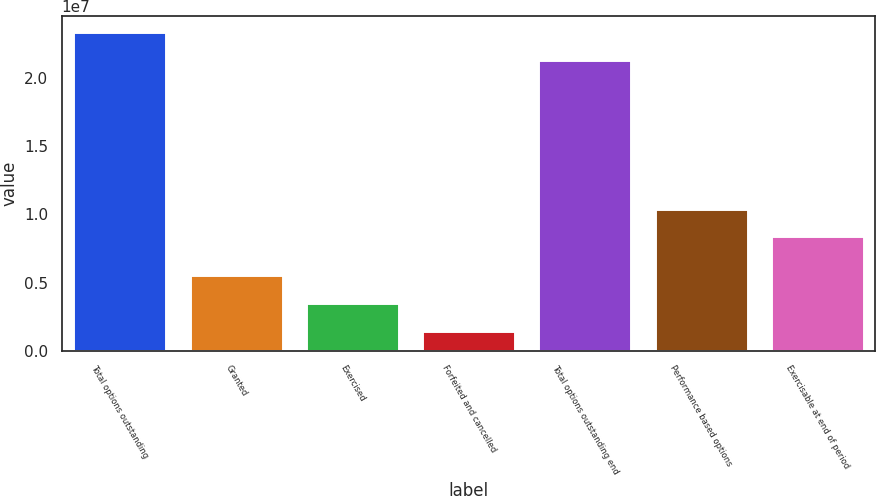<chart> <loc_0><loc_0><loc_500><loc_500><bar_chart><fcel>Total options outstanding<fcel>Granted<fcel>Exercised<fcel>Forfeited and cancelled<fcel>Total options outstanding end<fcel>Performance based options<fcel>Exercisable at end of period<nl><fcel>2.33799e+07<fcel>5.5685e+06<fcel>3.52475e+06<fcel>1.481e+06<fcel>2.13362e+07<fcel>1.04334e+07<fcel>8.38968e+06<nl></chart> 